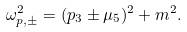Convert formula to latex. <formula><loc_0><loc_0><loc_500><loc_500>\omega _ { p , \pm } ^ { 2 } = ( p _ { 3 } \pm \mu _ { 5 } ) ^ { 2 } + m ^ { 2 } .</formula> 